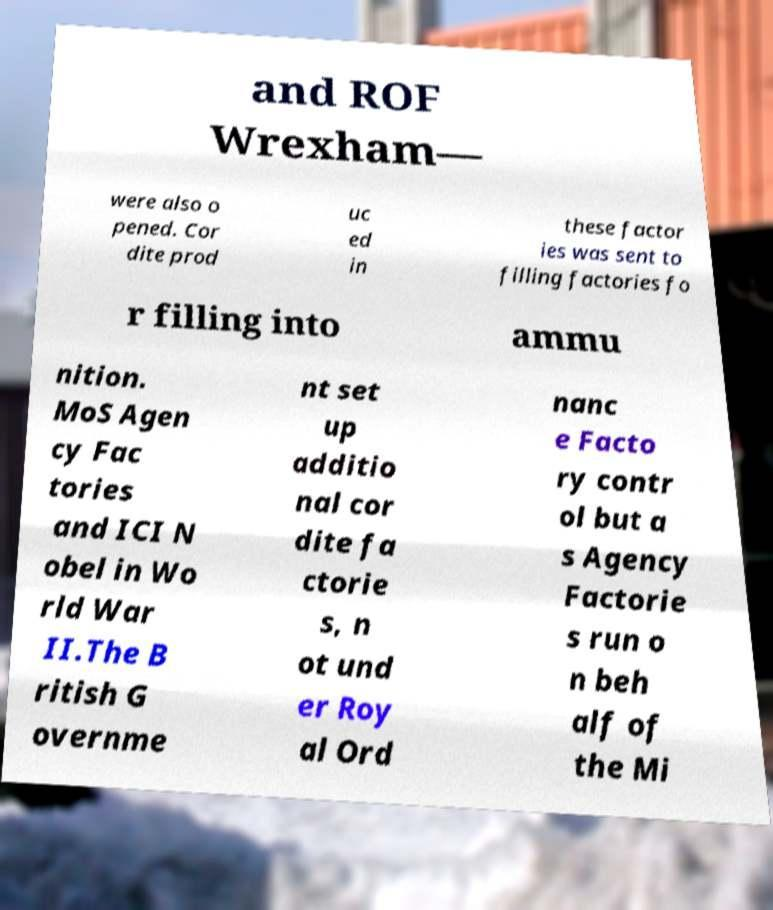There's text embedded in this image that I need extracted. Can you transcribe it verbatim? and ROF Wrexham— were also o pened. Cor dite prod uc ed in these factor ies was sent to filling factories fo r filling into ammu nition. MoS Agen cy Fac tories and ICI N obel in Wo rld War II.The B ritish G overnme nt set up additio nal cor dite fa ctorie s, n ot und er Roy al Ord nanc e Facto ry contr ol but a s Agency Factorie s run o n beh alf of the Mi 